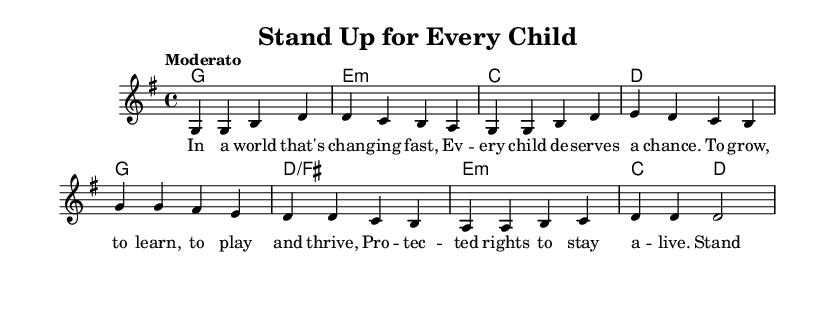What is the key signature of this music? The key signature is G major, which has one sharp (F#). This can be determined by the presence of one sharp in the key signature at the beginning of the staff.
Answer: G major What is the time signature of this music? The time signature is 4/4, which can be identified by looking at the notation marked at the beginning of the score. This indicates that there are 4 beats per measure.
Answer: 4/4 What is the tempo marking for this piece? The tempo marking is "Moderato." This is typically indicated at the beginning of the piece to provide guidance on the intended speed of the song.
Answer: Moderato How many measures are in the verse section? The verse section consists of 4 measures, as observed by counting each set of musical notes separated by a vertical line in that section.
Answer: 4 What is the first note of the chorus? The first note of the chorus is G. This can be confirmed by examining the melody line where the chorus begins.
Answer: G Which type of chord precedes the second line of the verse? The chord that precedes the second line of the verse is E minor. This can be identified in the harmonies section, where the chord is indicated for that measure.
Answer: E minor What is the structure type of this song? The song structure includes a verse followed by a chorus, as seen in the layout of the song. The verse leads into the chorus, which is a common pattern in songwriting.
Answer: Verse and chorus 